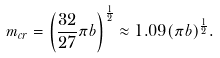<formula> <loc_0><loc_0><loc_500><loc_500>m _ { c r } = \left ( \frac { 3 2 } { 2 7 } \pi b \right ) ^ { \frac { 1 } { 2 } } \approx 1 . 0 9 ( \pi b ) ^ { \frac { 1 } { 2 } } .</formula> 